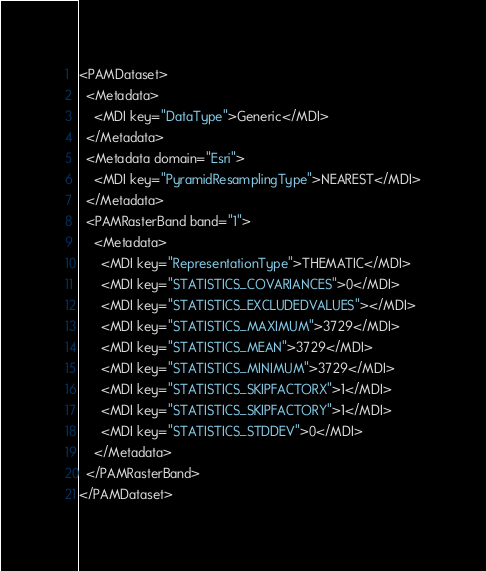Convert code to text. <code><loc_0><loc_0><loc_500><loc_500><_XML_><PAMDataset>
  <Metadata>
    <MDI key="DataType">Generic</MDI>
  </Metadata>
  <Metadata domain="Esri">
    <MDI key="PyramidResamplingType">NEAREST</MDI>
  </Metadata>
  <PAMRasterBand band="1">
    <Metadata>
      <MDI key="RepresentationType">THEMATIC</MDI>
      <MDI key="STATISTICS_COVARIANCES">0</MDI>
      <MDI key="STATISTICS_EXCLUDEDVALUES"></MDI>
      <MDI key="STATISTICS_MAXIMUM">3729</MDI>
      <MDI key="STATISTICS_MEAN">3729</MDI>
      <MDI key="STATISTICS_MINIMUM">3729</MDI>
      <MDI key="STATISTICS_SKIPFACTORX">1</MDI>
      <MDI key="STATISTICS_SKIPFACTORY">1</MDI>
      <MDI key="STATISTICS_STDDEV">0</MDI>
    </Metadata>
  </PAMRasterBand>
</PAMDataset>
</code> 